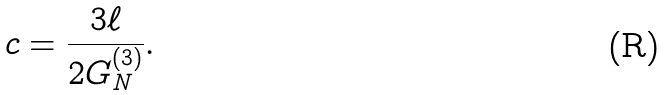Convert formula to latex. <formula><loc_0><loc_0><loc_500><loc_500>c = \frac { 3 \ell } { 2 G _ { N } ^ { ( 3 ) } } .</formula> 